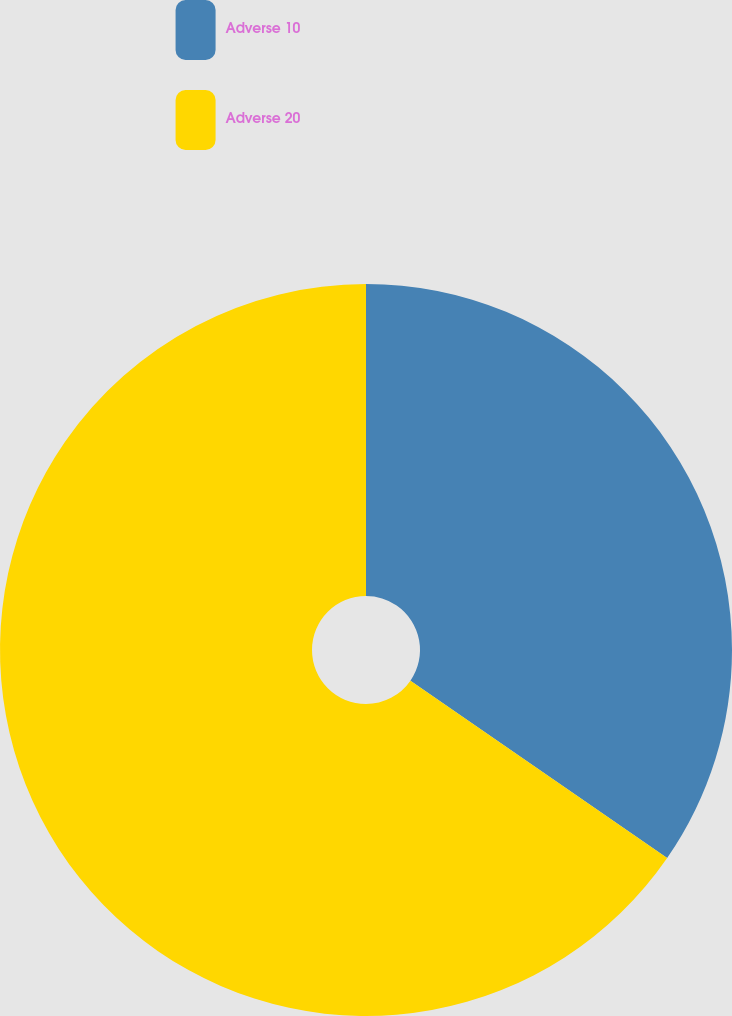<chart> <loc_0><loc_0><loc_500><loc_500><pie_chart><fcel>Adverse 10<fcel>Adverse 20<nl><fcel>34.62%<fcel>65.38%<nl></chart> 